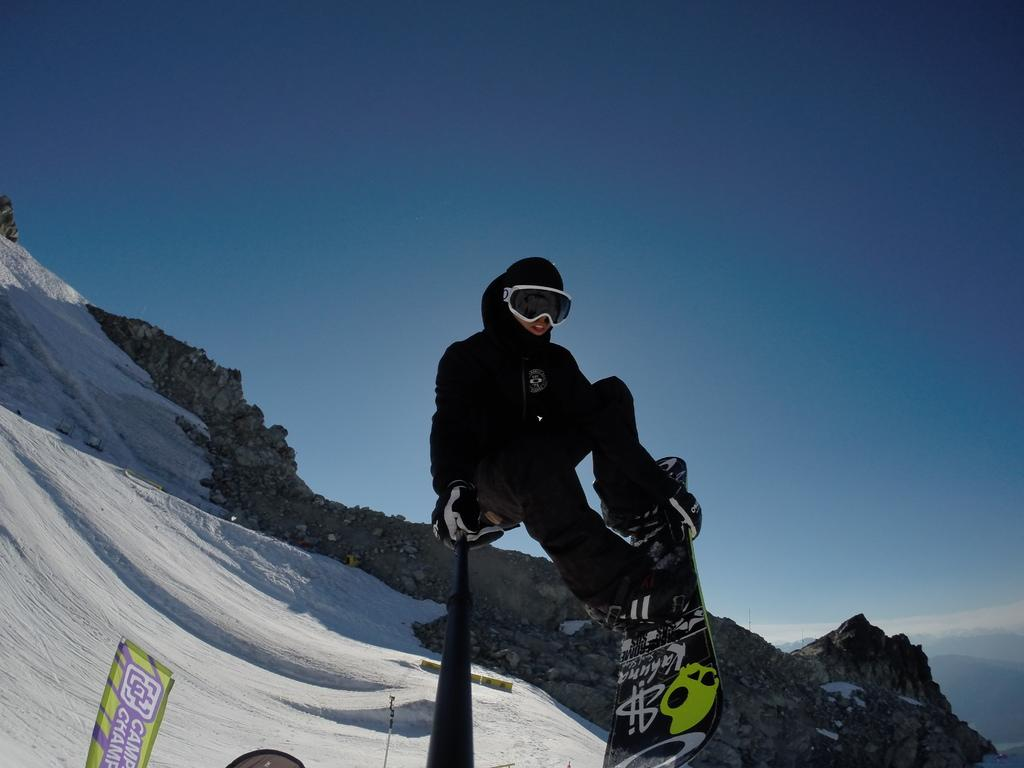Who is present in the image? There is a person in the image. What is the person doing in the image? The person is playing in the snow. What can be seen in the background of the image? There is a sky and mountains visible in the background of the image. What is the condition of the ground on the left side of the image? There is snow on the left side of the image. What type of bread is being used to improve the person's health in the image? There is no bread or reference to health in the image; it simply shows a person playing in the snow. 